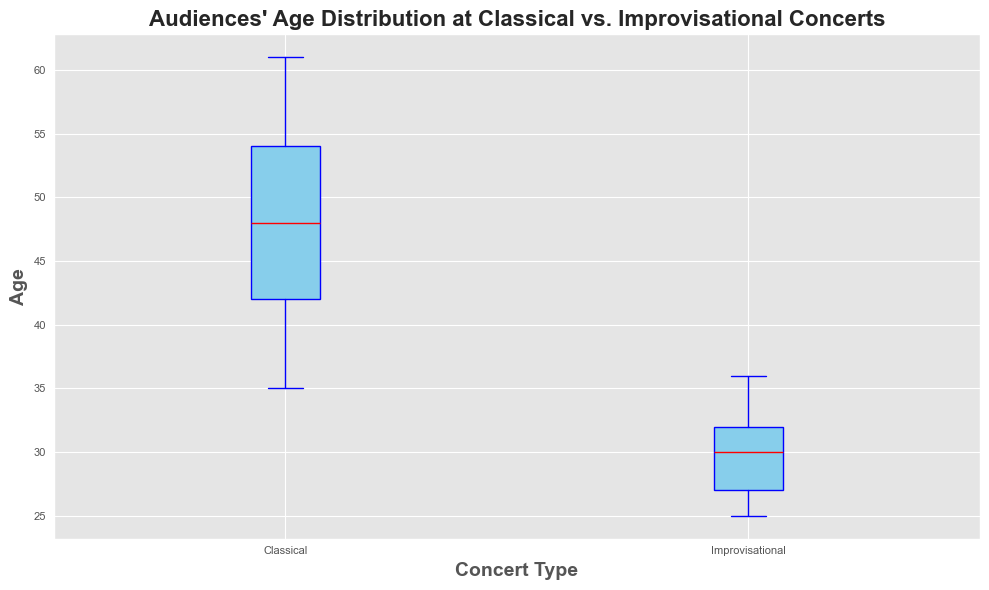What's the median age of the audience at classical concerts? To find the median age for classical concerts, you need to arrange the ages in ascending order and find the middle value. For 25 data points, the median would be the average of the 12th and 13th values. Here, those values are 47 and 48. Therefore, the median is (47+48)/2 = 47.5
Answer: 47.5 What's the median age of the audience at improvisational concerts? For improvisational concerts, you also arrange the ages in ascending order and find the middle value. With 25 data points, the median is the average of the 12th and 13th values. Here, those values are 29 and 30. Therefore, the median is (29+30)/2 = 29.5
Answer: 29.5 Which concert type has a higher median age? Compare the median ages of both concert types. The median age for classical concerts is 47.5, whereas for improvisational concerts, it is 29.5. Therefore, the classical concerts have a higher median age.
Answer: Classical concerts What is the range of ages for the audience at classical concerts? The range is calculated by subtracting the smallest age from the largest age for classical concerts. The smallest age is 35 and the largest is 61. The range is 61 - 35 = 26.
Answer: 26 What is the range of ages for the audience at improvisational concerts? Similarly, for improvisational concerts, subtract the smallest age from the largest age. The smallest age is 25 and the largest is 36. The range is 36 - 25 = 11.
Answer: 11 Which concert type has a broader range of audience ages? Compare the range of ages for both types. The classical concert range is 26 and the improvisational concert range is 11. Therefore, classical concerts have a broader range.
Answer: Classical concerts Are there any outliers in the audience ages for the classical concerts? In the box plot for classical concerts, outliers would be represented as individual points beyond the whiskers. There are no individual points plotted outside the whiskers, so there are no outliers.
Answer: No Are there any outliers in the audience ages for the improvisational concerts? Similar to classical concerts, examine the box plot for improvisational concerts. No individual points are plotted outside the whiskers, indicating there are no outliers.
Answer: No How do the interquartile ranges (IQR) of audience ages compare between the two concert types? The interquartile range (IQR) is the range between the first quartile (Q1) and the third quartile (Q3). Visually, estimate the box heights for both plots. The IQR for classical concerts appears larger than that for improvisational concerts.
Answer: Classical concerts' IQR is larger By how many years does the median age of the classical concert audience exceed that of the improvisational concert audience? Subtract the median age of the improvisational audience (29.5) from the median age of the classical audience (47.5). The result is 47.5 - 29.5 = 18 years.
Answer: 18 years 